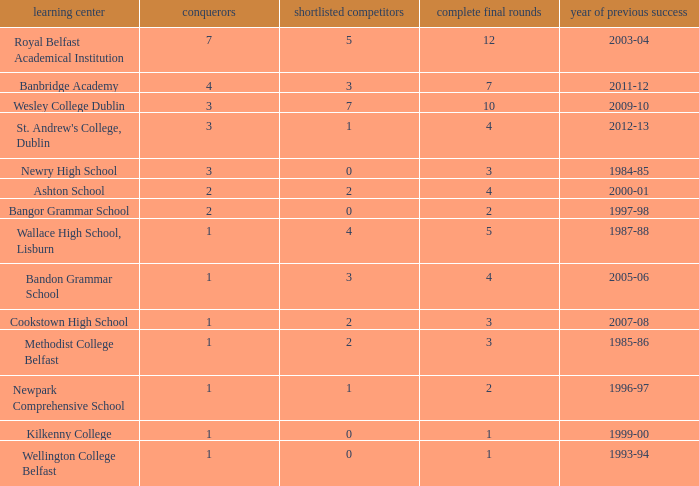What the name of  the school where the last win in 2007-08? Cookstown High School. Write the full table. {'header': ['learning center', 'conquerors', 'shortlisted competitors', 'complete final rounds', 'year of previous success'], 'rows': [['Royal Belfast Academical Institution', '7', '5', '12', '2003-04'], ['Banbridge Academy', '4', '3', '7', '2011-12'], ['Wesley College Dublin', '3', '7', '10', '2009-10'], ["St. Andrew's College, Dublin", '3', '1', '4', '2012-13'], ['Newry High School', '3', '0', '3', '1984-85'], ['Ashton School', '2', '2', '4', '2000-01'], ['Bangor Grammar School', '2', '0', '2', '1997-98'], ['Wallace High School, Lisburn', '1', '4', '5', '1987-88'], ['Bandon Grammar School', '1', '3', '4', '2005-06'], ['Cookstown High School', '1', '2', '3', '2007-08'], ['Methodist College Belfast', '1', '2', '3', '1985-86'], ['Newpark Comprehensive School', '1', '1', '2', '1996-97'], ['Kilkenny College', '1', '0', '1', '1999-00'], ['Wellington College Belfast', '1', '0', '1', '1993-94']]} 